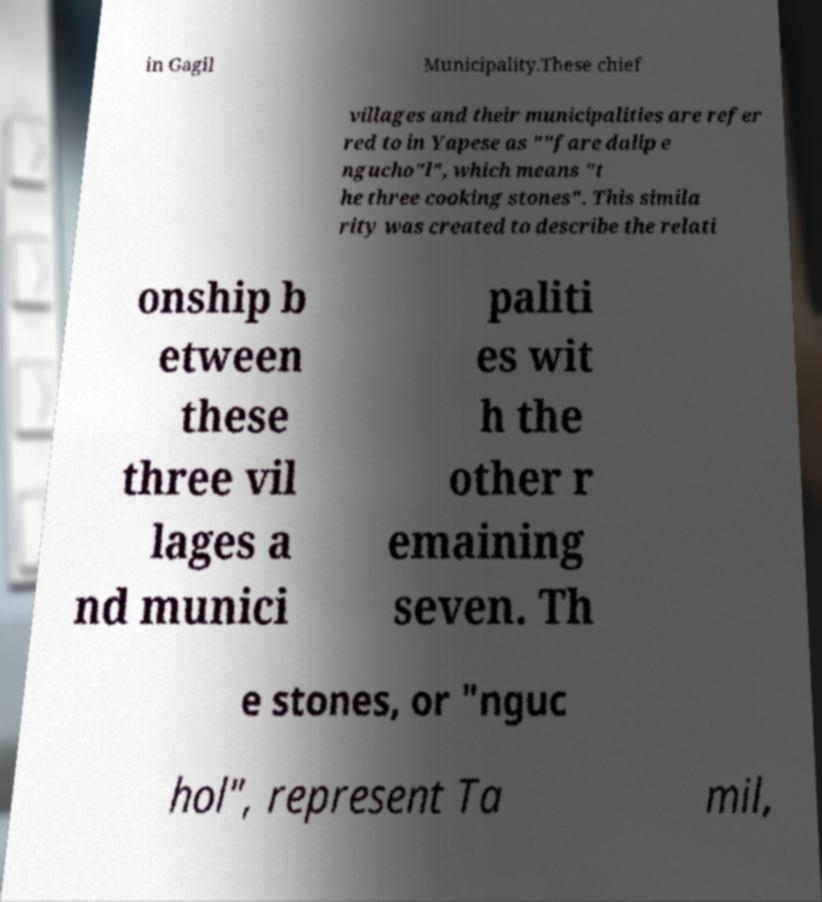Please identify and transcribe the text found in this image. in Gagil Municipality.These chief villages and their municipalities are refer red to in Yapese as ""fare dalip e ngucho"l", which means "t he three cooking stones". This simila rity was created to describe the relati onship b etween these three vil lages a nd munici paliti es wit h the other r emaining seven. Th e stones, or "nguc hol", represent Ta mil, 